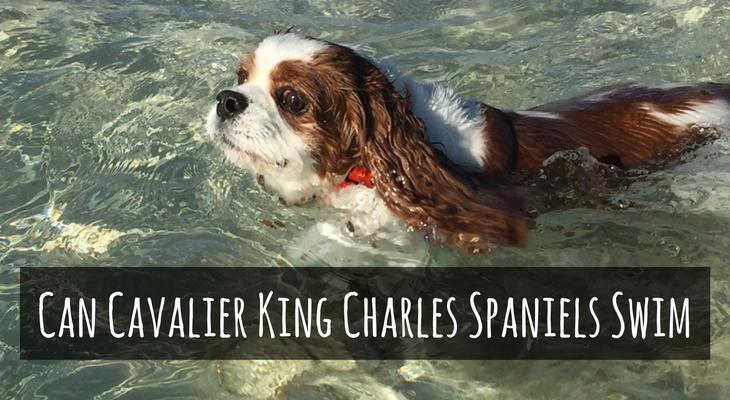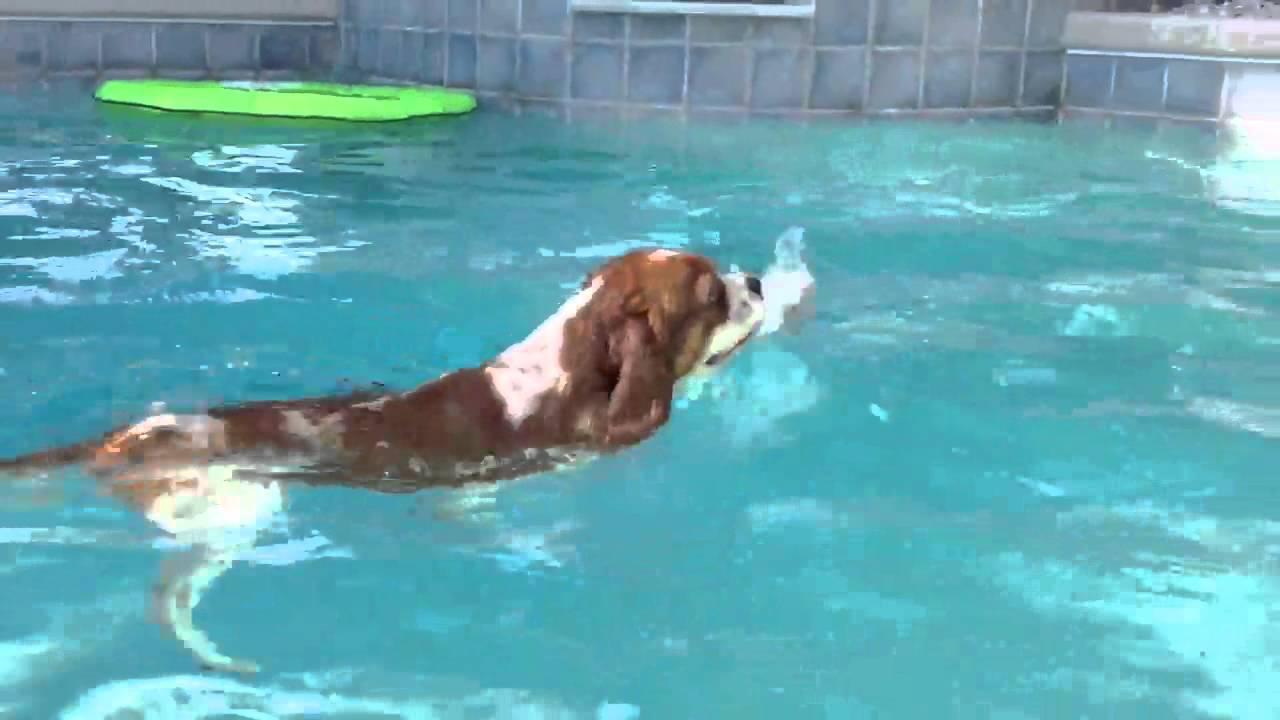The first image is the image on the left, the second image is the image on the right. Evaluate the accuracy of this statement regarding the images: "The righthand image shows a spaniel with a natural body of water, and the lefthand shows a spaniel in pool water.". Is it true? Answer yes or no. No. 